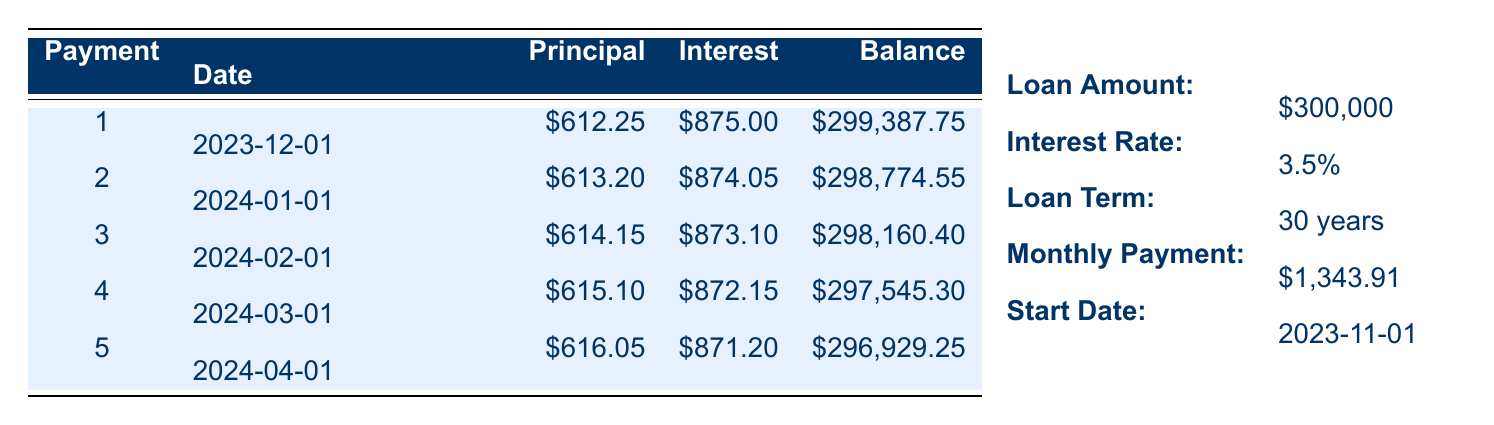What is the total principal paid after the first month? The principal payment for the first month is 612.25, so the total principal paid after one month is simply that amount.
Answer: 612.25 What is the interest payment for the second month? The interest payment for the second month is directly provided in the table, which shows it as 874.05.
Answer: 874.05 What is the remaining balance after the fifth payment? The table shows the remaining balance after the fifth payment as 296929.25.
Answer: 296929.25 How much total principal has been paid after the first five payments? To find the total principal paid after five payments, we add the principal amounts: 612.25 + 613.20 + 614.15 + 615.10 + 616.05 = 3,070.75.
Answer: 3070.75 Is the interest payment for the fourth month less than the third month? The interest payment for the fourth month is 872.15, and for the third month, it is 873.10. Since 872.15 is less than 873.10, the statement is true.
Answer: Yes Which month has the highest principal payment among the first five payments? The principal payment amounts are 612.25, 613.20, 614.15, 615.10, and 616.05. Comparing these, 616.05 in the fifth payment is the highest.
Answer: Fifth month What were your total payments for the first half of the first year? The total monthly payments for the first five months are 1343.91 each month, so for five months, it is 1343.91 * 5 = 6719.55.
Answer: 6719.55 How much interest do you pay cumulatively after the first three months? The cumulative interest payments for the first three months are 875.00 + 874.05 + 873.10 = 2622.15.
Answer: 2622.15 Is there a decrease in interest payment from the first month to the second month? The interest payments are 875.00 for the first month and 874.05 for the second month, indicating a decrease.
Answer: Yes 